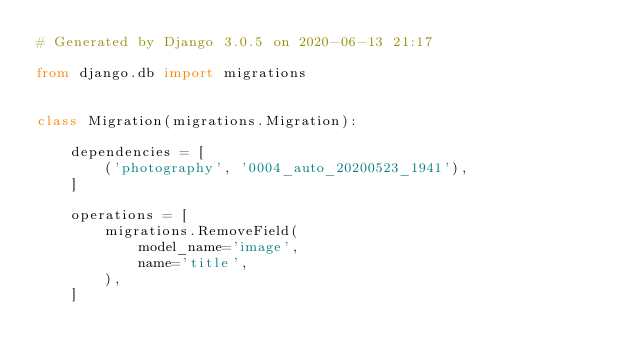<code> <loc_0><loc_0><loc_500><loc_500><_Python_># Generated by Django 3.0.5 on 2020-06-13 21:17

from django.db import migrations


class Migration(migrations.Migration):

    dependencies = [
        ('photography', '0004_auto_20200523_1941'),
    ]

    operations = [
        migrations.RemoveField(
            model_name='image',
            name='title',
        ),
    ]
</code> 